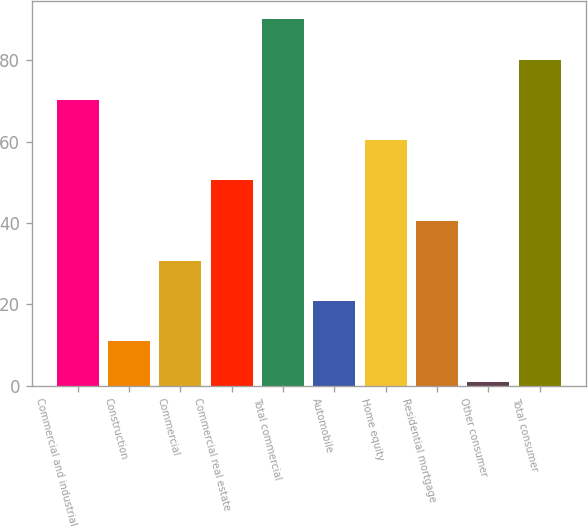Convert chart to OTSL. <chart><loc_0><loc_0><loc_500><loc_500><bar_chart><fcel>Commercial and industrial<fcel>Construction<fcel>Commercial<fcel>Commercial real estate<fcel>Total commercial<fcel>Automobile<fcel>Home equity<fcel>Residential mortgage<fcel>Other consumer<fcel>Total consumer<nl><fcel>70.3<fcel>10.9<fcel>30.7<fcel>50.5<fcel>90.1<fcel>20.8<fcel>60.4<fcel>40.6<fcel>1<fcel>80.2<nl></chart> 